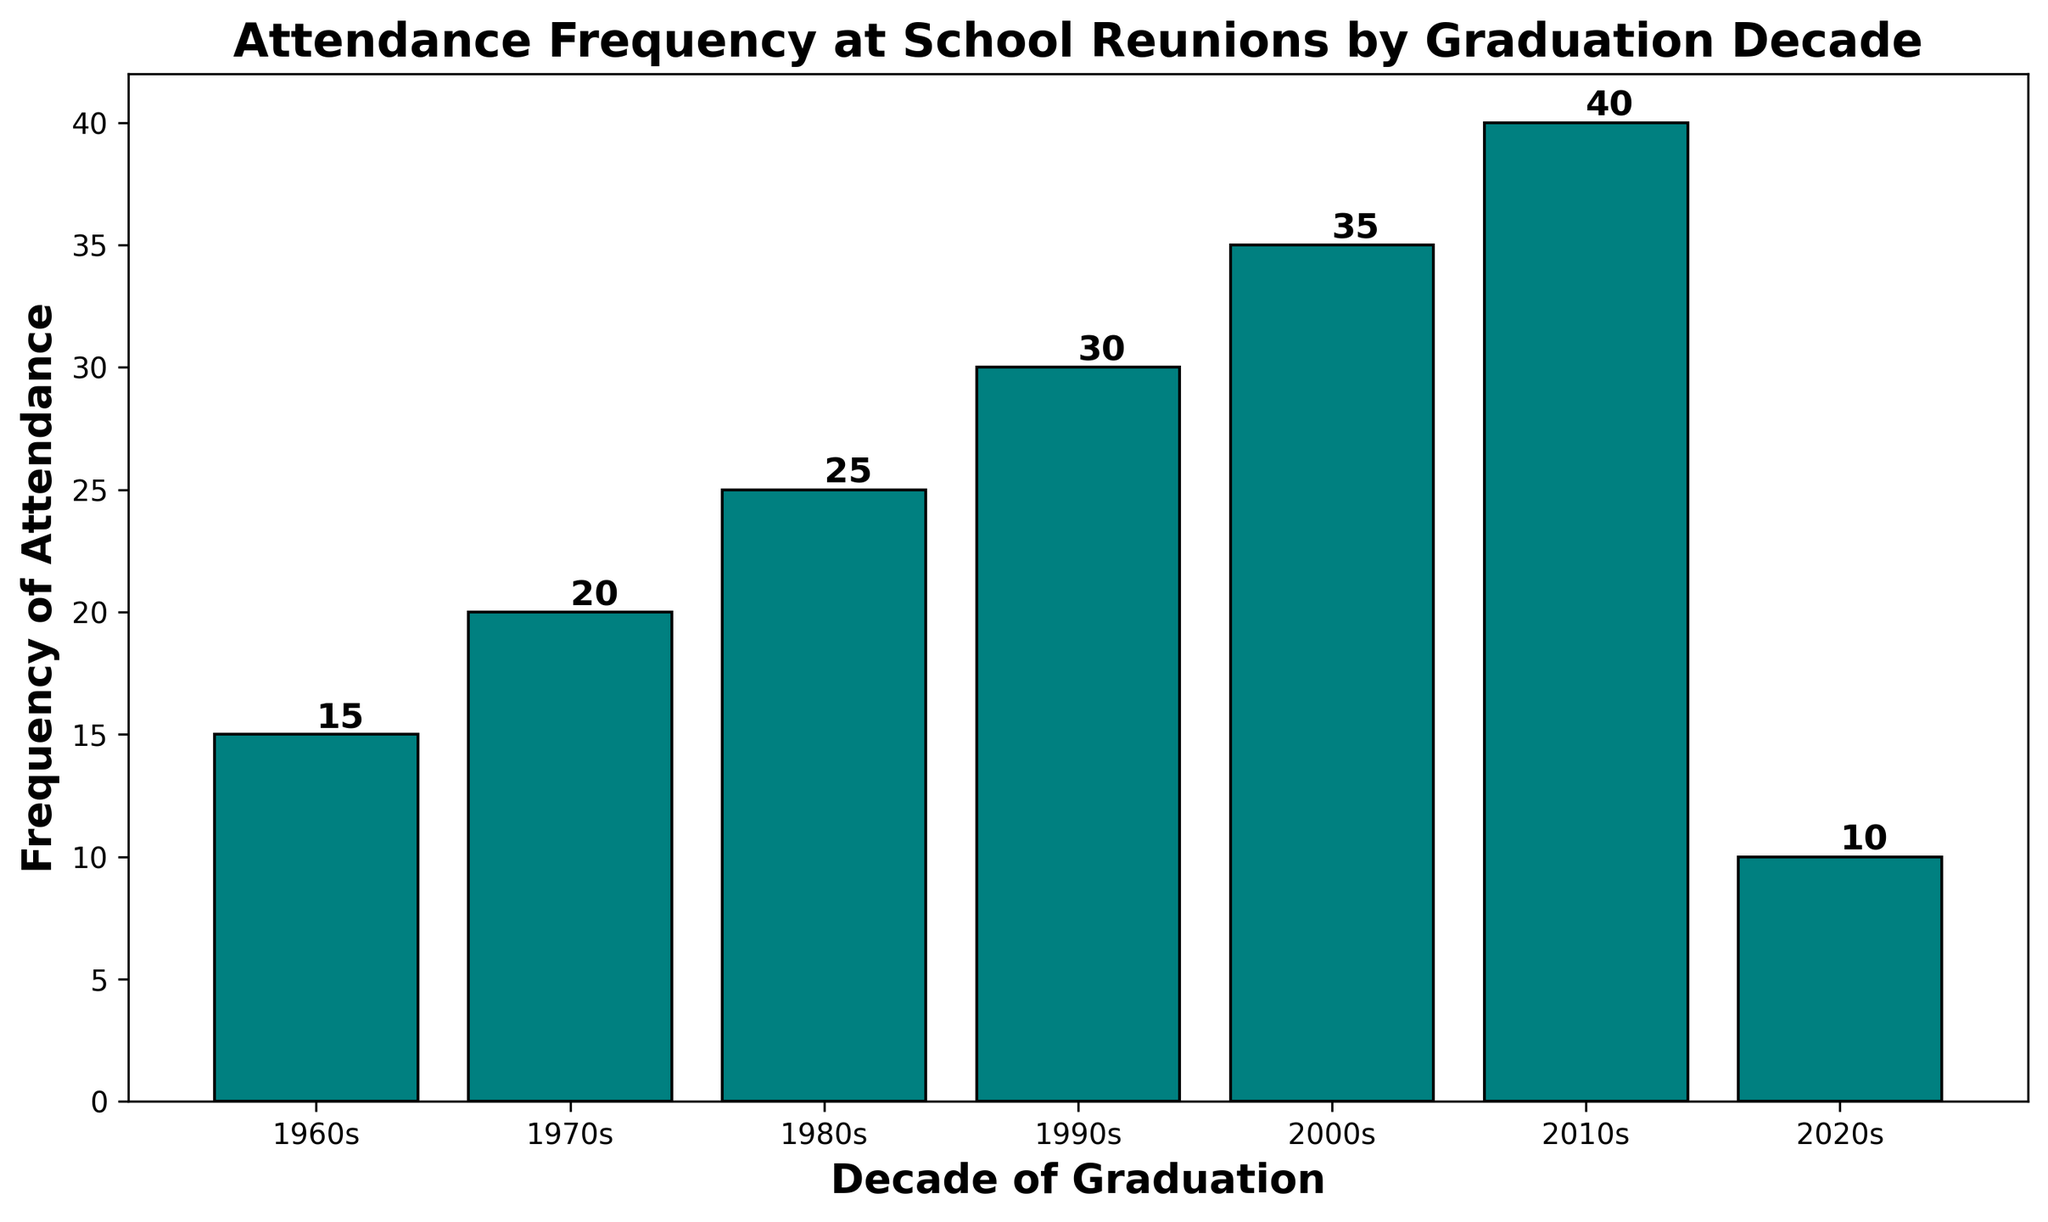What is the frequency of attendance for the 1980s? Look for the bar labeled "1980s" and check the height value or the text label on top of it.
Answer: 25 Which decade shows the highest frequency of attendance? Identify the bar that is the tallest or has the largest value label on top.
Answer: 2010s How much higher is the frequency of attendance in the 2000s compared to the 2020s? Find the heights of the bars labeled "2000s" and "2020s," then calculate the difference. 35 - 10 = 25.
Answer: 25 What's the average frequency of attendance across all decades? Sum up the frequencies of all the decades and divide by the number of decades. (15 + 20 + 25 + 30 + 35 + 40 + 10) / 7 = 175 / 7 ≈ 25.
Answer: 25 Is the frequency of attendance for the 1990s less than that for the 2010s? Compare the heights or the value labels of the bars for "1990s" and "2010s." 30 < 40.
Answer: Yes Which two consecutive decades have the largest increase in attendance frequency? Check the differences in frequencies between consecutive decades and identify the largest. Largest increase is between 2000s (35) to 2010s (40).
Answer: 2000s to 2010s What is the total frequency for the decades 1970s, 1980s, and 1990s combined? Sum the frequencies for the decades 1970s, 1980s, and 1990s. 20 + 25 + 30 = 75.
Answer: 75 Which decade has the lowest attendance frequency? Identify the bar with the smallest height or value label.
Answer: 2020s How does the frequency in the 2010s compare to the average frequency across all decades? Calculate the average frequency (25) and compare it to the frequency of the 2010s (40). 40 > 25.
Answer: Greater What is the trend in attendance frequency from the 1960s to the 2010s? Observe the general pattern in the heights of the bars from 1960s to 2010s. Frequencies generally increase with each decade.
Answer: Increasing 